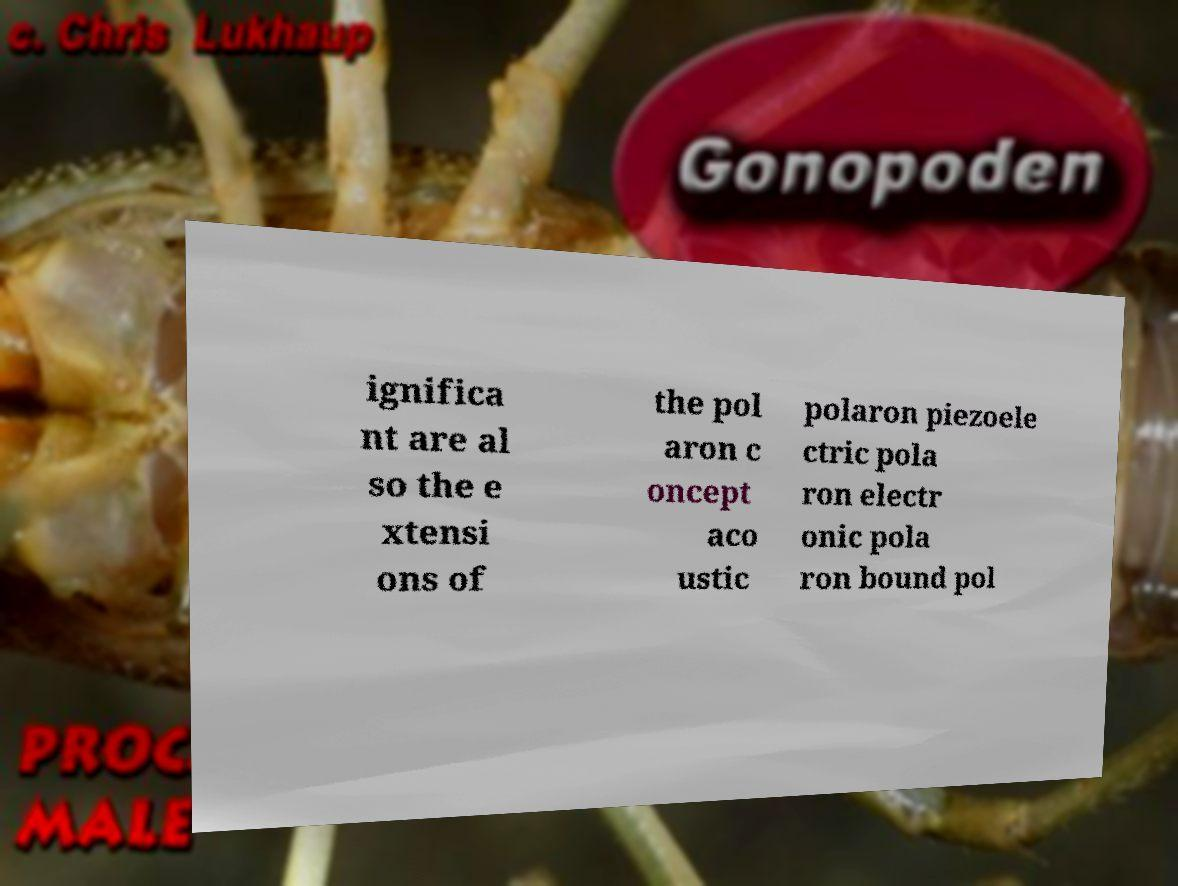What messages or text are displayed in this image? I need them in a readable, typed format. ignifica nt are al so the e xtensi ons of the pol aron c oncept aco ustic polaron piezoele ctric pola ron electr onic pola ron bound pol 